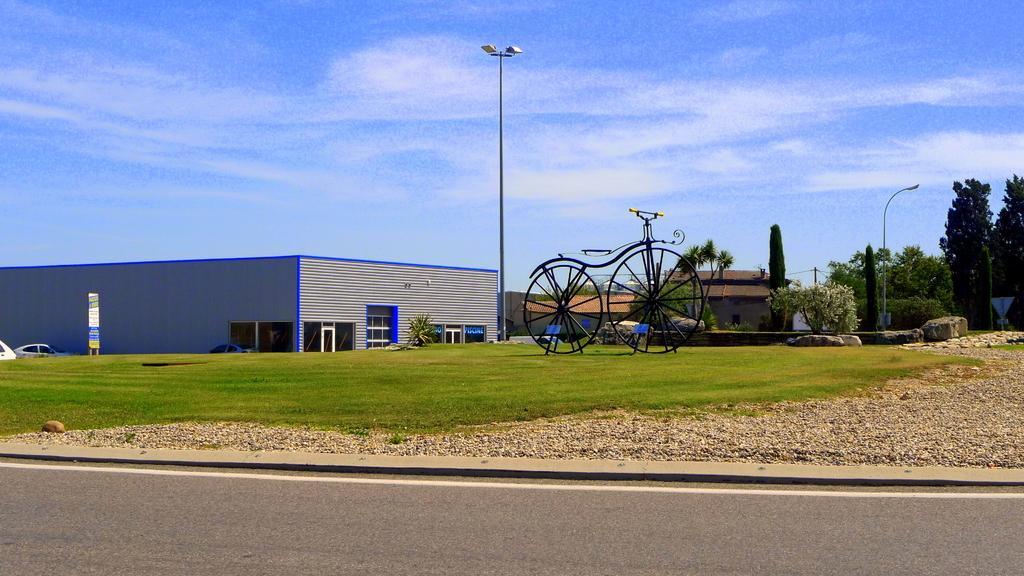Could you give a brief overview of what you see in this image? In this picture, it looks like a statue of a bicycle. Behind the statue there are houses, trees, rocks and poles with lights. On the left side of the statue there is a board and vehicles. Behind the houses there is the sky. 